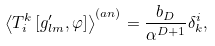<formula> <loc_0><loc_0><loc_500><loc_500>\left \langle T _ { i } ^ { k } \left [ g ^ { \prime } _ { l m } , \varphi \right ] \right \rangle ^ { ( a n ) } = \frac { b _ { D } } { \alpha ^ { D + 1 } } \delta ^ { i } _ { k } ,</formula> 